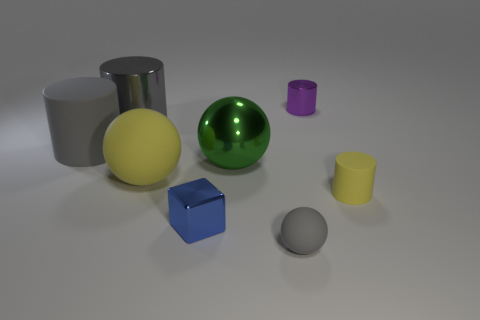What number of other objects are there of the same color as the small cube?
Your response must be concise. 0. There is a gray metallic thing; are there any small blocks behind it?
Make the answer very short. No. The block that is in front of the tiny cylinder that is on the left side of the cylinder in front of the big yellow object is what color?
Your answer should be very brief. Blue. What number of rubber cylinders are both to the left of the purple object and in front of the large gray rubber thing?
Your answer should be compact. 0. How many cylinders are tiny yellow things or small gray matte things?
Give a very brief answer. 1. Are there any large purple matte blocks?
Offer a very short reply. No. What number of other objects are there of the same material as the yellow sphere?
Provide a succinct answer. 3. What is the material of the purple cylinder that is the same size as the blue object?
Provide a short and direct response. Metal. Do the yellow object that is right of the big yellow thing and the small purple metal thing have the same shape?
Your answer should be compact. Yes. Is the small ball the same color as the large metallic cylinder?
Ensure brevity in your answer.  Yes. 